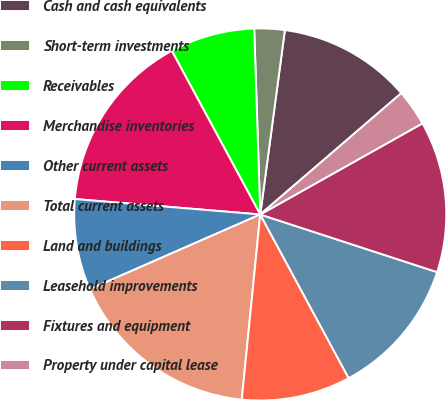Convert chart to OTSL. <chart><loc_0><loc_0><loc_500><loc_500><pie_chart><fcel>Cash and cash equivalents<fcel>Short-term investments<fcel>Receivables<fcel>Merchandise inventories<fcel>Other current assets<fcel>Total current assets<fcel>Land and buildings<fcel>Leasehold improvements<fcel>Fixtures and equipment<fcel>Property under capital lease<nl><fcel>11.58%<fcel>2.63%<fcel>7.37%<fcel>15.79%<fcel>7.9%<fcel>16.84%<fcel>9.47%<fcel>12.1%<fcel>13.16%<fcel>3.16%<nl></chart> 